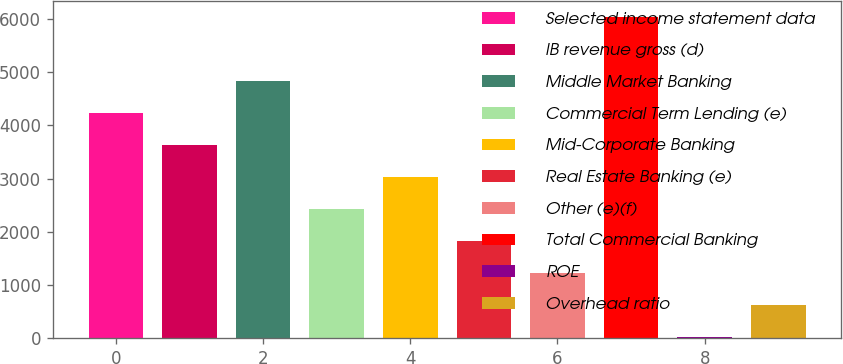Convert chart. <chart><loc_0><loc_0><loc_500><loc_500><bar_chart><fcel>Selected income statement data<fcel>IB revenue gross (d)<fcel>Middle Market Banking<fcel>Commercial Term Lending (e)<fcel>Mid-Corporate Banking<fcel>Real Estate Banking (e)<fcel>Other (e)(f)<fcel>Total Commercial Banking<fcel>ROE<fcel>Overhead ratio<nl><fcel>4235.8<fcel>3634.4<fcel>4837.2<fcel>2431.6<fcel>3033<fcel>1830.2<fcel>1228.8<fcel>6040<fcel>26<fcel>627.4<nl></chart> 